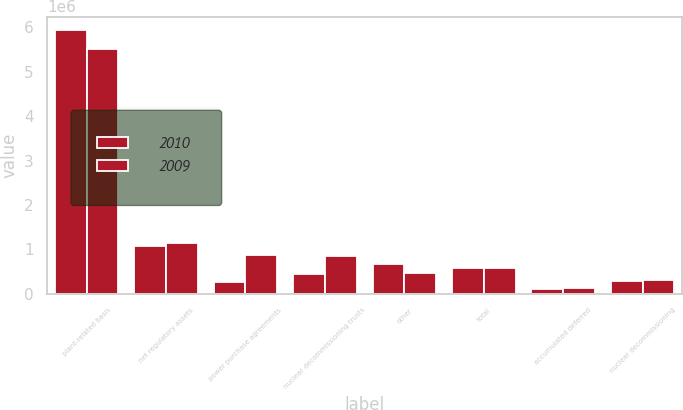Convert chart to OTSL. <chart><loc_0><loc_0><loc_500><loc_500><stacked_bar_chart><ecel><fcel>plant-related basis<fcel>net regulatory assets<fcel>power purchase agreements<fcel>nuclear decommissioning trusts<fcel>other<fcel>total<fcel>accumulated deferred<fcel>nuclear decommissioning<nl><fcel>2010<fcel>5.94776e+06<fcel>1.07413e+06<fcel>265429<fcel>439481<fcel>679302<fcel>567678<fcel>111170<fcel>285889<nl><fcel>2009<fcel>5.5201e+06<fcel>1.14771e+06<fcel>862322<fcel>855608<fcel>456053<fcel>567678<fcel>118587<fcel>313648<nl></chart> 